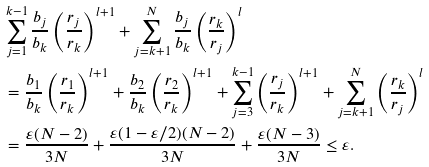Convert formula to latex. <formula><loc_0><loc_0><loc_500><loc_500>& \sum ^ { k - 1 } _ { j = 1 } \frac { b _ { j } } { b _ { k } } \left ( \frac { r _ { j } } { r _ { k } } \right ) ^ { l + 1 } + \sum ^ { N } _ { j = k + 1 } \frac { b _ { j } } { b _ { k } } \left ( \frac { r _ { k } } { r _ { j } } \right ) ^ { l } \\ & = \frac { b _ { 1 } } { b _ { k } } \left ( \frac { r _ { 1 } } { r _ { k } } \right ) ^ { l + 1 } + \frac { b _ { 2 } } { b _ { k } } \left ( \frac { r _ { 2 } } { r _ { k } } \right ) ^ { l + 1 } + \sum _ { j = 3 } ^ { k - 1 } \left ( \frac { r _ { j } } { r _ { k } } \right ) ^ { l + 1 } + \sum _ { j = k + 1 } ^ { N } \left ( \frac { r _ { k } } { r _ { j } } \right ) ^ { l } \\ & = \frac { \varepsilon ( N - 2 ) } { 3 N } + \frac { \varepsilon ( 1 - \varepsilon / 2 ) ( N - 2 ) } { 3 N } + \frac { \varepsilon ( N - 3 ) } { 3 N } \leq \varepsilon .</formula> 